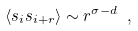<formula> <loc_0><loc_0><loc_500><loc_500>\langle s _ { i } s _ { i + r } \rangle \sim r ^ { \sigma - d } \ ,</formula> 